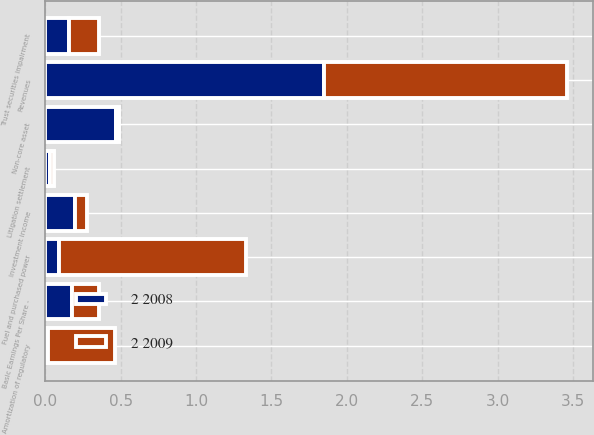<chart> <loc_0><loc_0><loc_500><loc_500><stacked_bar_chart><ecel><fcel>Basic Earnings Per Share -<fcel>Non-core asset<fcel>Litigation settlement<fcel>Trust securities impairment<fcel>Revenues<fcel>Fuel and purchased power<fcel>Amortization of regulatory<fcel>Investment income<nl><fcel>2 2008<fcel>0.18<fcel>0.47<fcel>0.03<fcel>0.16<fcel>1.85<fcel>0.09<fcel>0.02<fcel>0.2<nl><fcel>2 2009<fcel>0.18<fcel>0.02<fcel>0.03<fcel>0.2<fcel>1.61<fcel>1.24<fcel>0.44<fcel>0.08<nl></chart> 